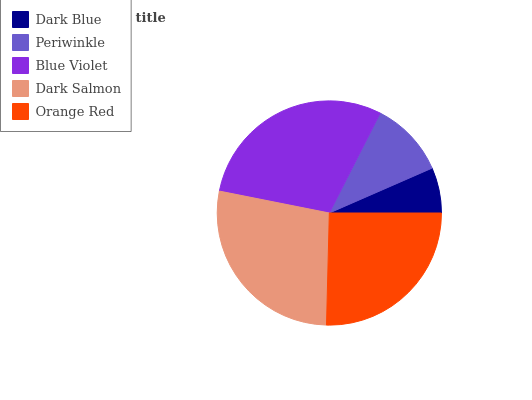Is Dark Blue the minimum?
Answer yes or no. Yes. Is Blue Violet the maximum?
Answer yes or no. Yes. Is Periwinkle the minimum?
Answer yes or no. No. Is Periwinkle the maximum?
Answer yes or no. No. Is Periwinkle greater than Dark Blue?
Answer yes or no. Yes. Is Dark Blue less than Periwinkle?
Answer yes or no. Yes. Is Dark Blue greater than Periwinkle?
Answer yes or no. No. Is Periwinkle less than Dark Blue?
Answer yes or no. No. Is Orange Red the high median?
Answer yes or no. Yes. Is Orange Red the low median?
Answer yes or no. Yes. Is Periwinkle the high median?
Answer yes or no. No. Is Periwinkle the low median?
Answer yes or no. No. 